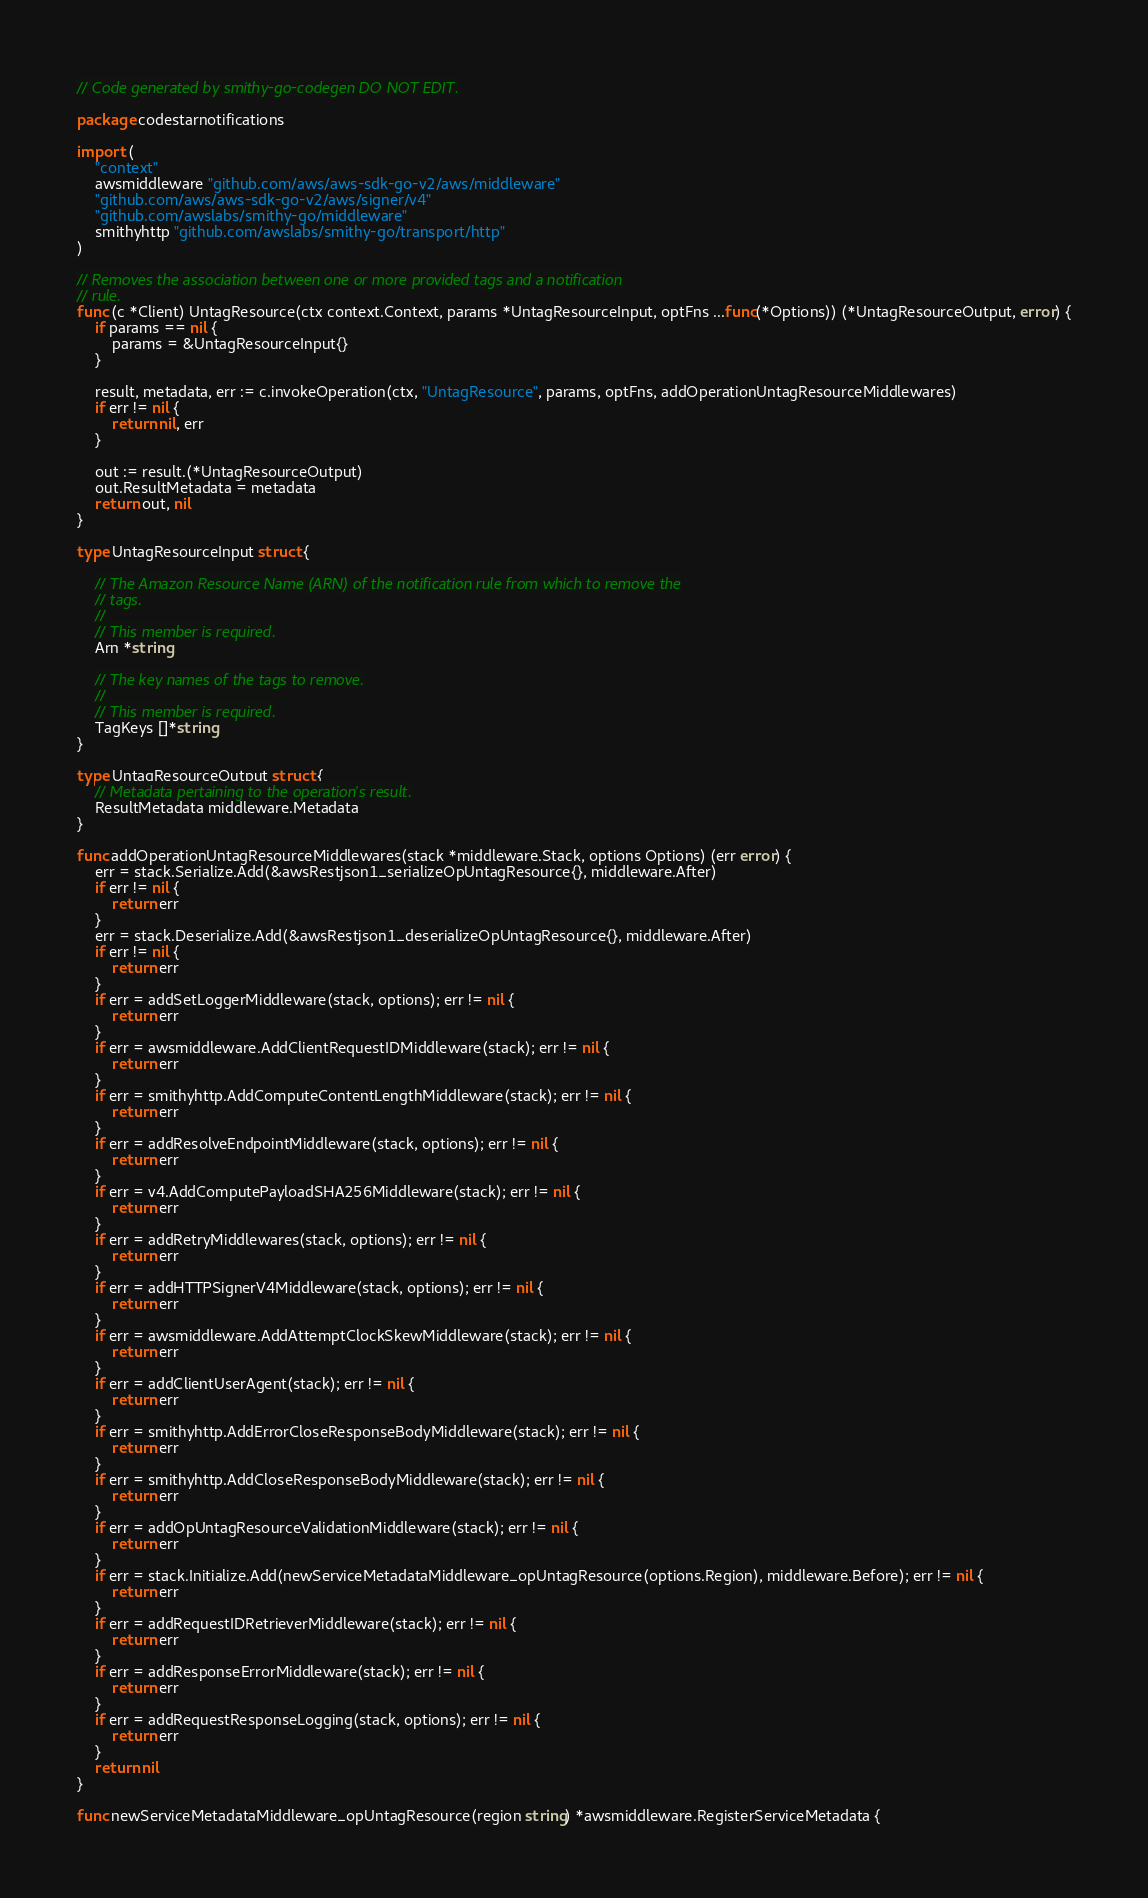<code> <loc_0><loc_0><loc_500><loc_500><_Go_>// Code generated by smithy-go-codegen DO NOT EDIT.

package codestarnotifications

import (
	"context"
	awsmiddleware "github.com/aws/aws-sdk-go-v2/aws/middleware"
	"github.com/aws/aws-sdk-go-v2/aws/signer/v4"
	"github.com/awslabs/smithy-go/middleware"
	smithyhttp "github.com/awslabs/smithy-go/transport/http"
)

// Removes the association between one or more provided tags and a notification
// rule.
func (c *Client) UntagResource(ctx context.Context, params *UntagResourceInput, optFns ...func(*Options)) (*UntagResourceOutput, error) {
	if params == nil {
		params = &UntagResourceInput{}
	}

	result, metadata, err := c.invokeOperation(ctx, "UntagResource", params, optFns, addOperationUntagResourceMiddlewares)
	if err != nil {
		return nil, err
	}

	out := result.(*UntagResourceOutput)
	out.ResultMetadata = metadata
	return out, nil
}

type UntagResourceInput struct {

	// The Amazon Resource Name (ARN) of the notification rule from which to remove the
	// tags.
	//
	// This member is required.
	Arn *string

	// The key names of the tags to remove.
	//
	// This member is required.
	TagKeys []*string
}

type UntagResourceOutput struct {
	// Metadata pertaining to the operation's result.
	ResultMetadata middleware.Metadata
}

func addOperationUntagResourceMiddlewares(stack *middleware.Stack, options Options) (err error) {
	err = stack.Serialize.Add(&awsRestjson1_serializeOpUntagResource{}, middleware.After)
	if err != nil {
		return err
	}
	err = stack.Deserialize.Add(&awsRestjson1_deserializeOpUntagResource{}, middleware.After)
	if err != nil {
		return err
	}
	if err = addSetLoggerMiddleware(stack, options); err != nil {
		return err
	}
	if err = awsmiddleware.AddClientRequestIDMiddleware(stack); err != nil {
		return err
	}
	if err = smithyhttp.AddComputeContentLengthMiddleware(stack); err != nil {
		return err
	}
	if err = addResolveEndpointMiddleware(stack, options); err != nil {
		return err
	}
	if err = v4.AddComputePayloadSHA256Middleware(stack); err != nil {
		return err
	}
	if err = addRetryMiddlewares(stack, options); err != nil {
		return err
	}
	if err = addHTTPSignerV4Middleware(stack, options); err != nil {
		return err
	}
	if err = awsmiddleware.AddAttemptClockSkewMiddleware(stack); err != nil {
		return err
	}
	if err = addClientUserAgent(stack); err != nil {
		return err
	}
	if err = smithyhttp.AddErrorCloseResponseBodyMiddleware(stack); err != nil {
		return err
	}
	if err = smithyhttp.AddCloseResponseBodyMiddleware(stack); err != nil {
		return err
	}
	if err = addOpUntagResourceValidationMiddleware(stack); err != nil {
		return err
	}
	if err = stack.Initialize.Add(newServiceMetadataMiddleware_opUntagResource(options.Region), middleware.Before); err != nil {
		return err
	}
	if err = addRequestIDRetrieverMiddleware(stack); err != nil {
		return err
	}
	if err = addResponseErrorMiddleware(stack); err != nil {
		return err
	}
	if err = addRequestResponseLogging(stack, options); err != nil {
		return err
	}
	return nil
}

func newServiceMetadataMiddleware_opUntagResource(region string) *awsmiddleware.RegisterServiceMetadata {</code> 